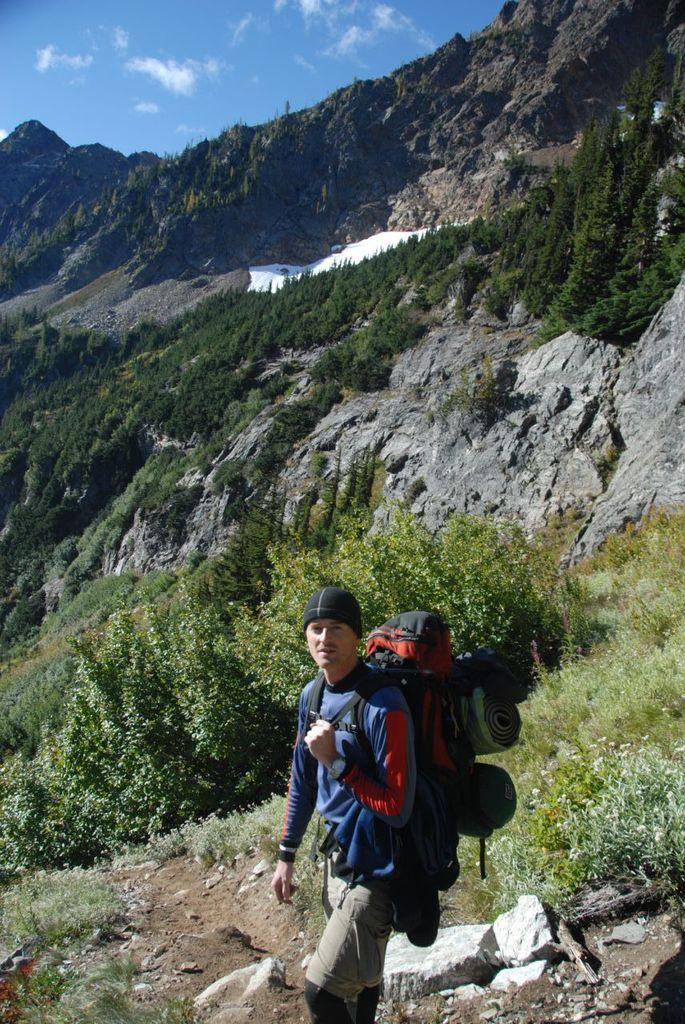What is the man in the image doing? The man is standing in the image. What is the man carrying in the image? The man is carrying an orange bag. What is the man wearing in the image? The man is wearing a blue t-shirt. What can be seen in the background of the image? Mountains, trees, and the sky are visible in the background of the image. What type of jar is the man holding in the image? There is no jar present in the image; the man is carrying an orange bag. How many cannons can be seen in the image? There are no cannons present in the image. 